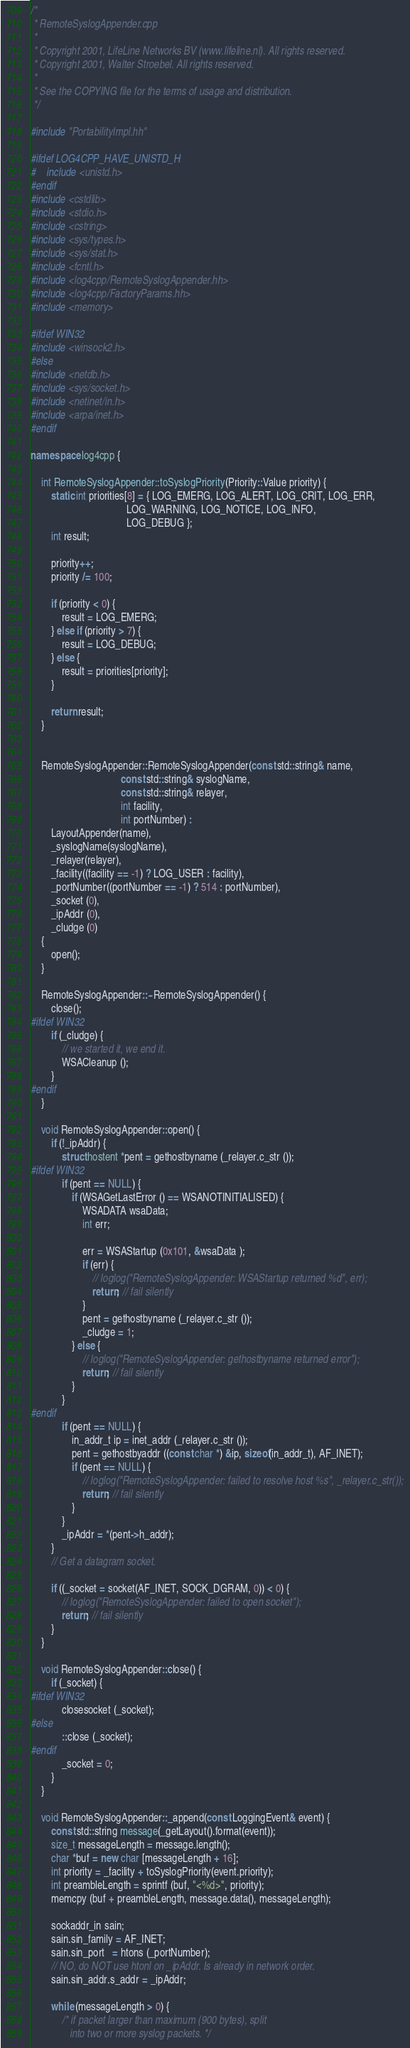<code> <loc_0><loc_0><loc_500><loc_500><_C++_>/*
 * RemoteSyslogAppender.cpp
 *
 * Copyright 2001, LifeLine Networks BV (www.lifeline.nl). All rights reserved.
 * Copyright 2001, Walter Stroebel. All rights reserved.
 *
 * See the COPYING file for the terms of usage and distribution.
 */

#include "PortabilityImpl.hh"

#ifdef LOG4CPP_HAVE_UNISTD_H
#    include <unistd.h>
#endif
#include <cstdlib>
#include <stdio.h>
#include <cstring>
#include <sys/types.h>
#include <sys/stat.h>
#include <fcntl.h>
#include <log4cpp/RemoteSyslogAppender.hh>
#include <log4cpp/FactoryParams.hh>
#include <memory>

#ifdef WIN32
#include <winsock2.h>
#else
#include <netdb.h>
#include <sys/socket.h>
#include <netinet/in.h>
#include <arpa/inet.h>
#endif

namespace log4cpp {

    int RemoteSyslogAppender::toSyslogPriority(Priority::Value priority) {
        static int priorities[8] = { LOG_EMERG, LOG_ALERT, LOG_CRIT, LOG_ERR,
                                     LOG_WARNING, LOG_NOTICE, LOG_INFO, 
                                     LOG_DEBUG };
        int result;

        priority++;
        priority /= 100;

        if (priority < 0) {
            result = LOG_EMERG;
        } else if (priority > 7) {
            result = LOG_DEBUG;
        } else {
            result = priorities[priority];
        }

        return result;
    }
        

    RemoteSyslogAppender::RemoteSyslogAppender(const std::string& name, 
                                   const std::string& syslogName, 
                                   const std::string& relayer,
                                   int facility,
                                   int portNumber) : 
        LayoutAppender(name),
        _syslogName(syslogName),
        _relayer(relayer),
        _facility((facility == -1) ? LOG_USER : facility),
        _portNumber((portNumber == -1) ? 514 : portNumber),
        _socket (0),
        _ipAddr (0),
        _cludge (0)
    {
        open();
    }
    
    RemoteSyslogAppender::~RemoteSyslogAppender() {
        close();
#ifdef WIN32
        if (_cludge) {
            // we started it, we end it.
            WSACleanup ();
        }
#endif
    }

    void RemoteSyslogAppender::open() {
        if (!_ipAddr) {
            struct hostent *pent = gethostbyname (_relayer.c_str ());
#ifdef WIN32
            if (pent == NULL) {
                if (WSAGetLastError () == WSANOTINITIALISED) {
                    WSADATA wsaData;
                    int err;
 
                    err = WSAStartup (0x101, &wsaData );
                    if (err) {
                        // loglog("RemoteSyslogAppender: WSAStartup returned %d", err);
                        return; // fail silently
                    }
                    pent = gethostbyname (_relayer.c_str ());
                    _cludge = 1;
                } else {
                    // loglog("RemoteSyslogAppender: gethostbyname returned error");
                    return; // fail silently
                }
            }
#endif
            if (pent == NULL) {
                in_addr_t ip = inet_addr (_relayer.c_str ());
                pent = gethostbyaddr ((const char *) &ip, sizeof(in_addr_t), AF_INET);
                if (pent == NULL) {
                    // loglog("RemoteSyslogAppender: failed to resolve host %s", _relayer.c_str());
                    return; // fail silently                    
                }
            }
            _ipAddr = *(pent->h_addr);
        }
        // Get a datagram socket.
        
        if ((_socket = socket(AF_INET, SOCK_DGRAM, 0)) < 0) {
            // loglog("RemoteSyslogAppender: failed to open socket");
            return; // fail silently                    
        }
    }

    void RemoteSyslogAppender::close() {
        if (_socket) {
#ifdef WIN32
            closesocket (_socket);
#else
            ::close (_socket);
#endif
            _socket = 0;
        }
    }

    void RemoteSyslogAppender::_append(const LoggingEvent& event) {
        const std::string message(_getLayout().format(event));
        size_t messageLength = message.length();
        char *buf = new char [messageLength + 16];
        int priority = _facility + toSyslogPriority(event.priority);
        int preambleLength = sprintf (buf, "<%d>", priority);
        memcpy (buf + preambleLength, message.data(), messageLength);

        sockaddr_in sain;
        sain.sin_family = AF_INET;
        sain.sin_port   = htons (_portNumber);
        // NO, do NOT use htonl on _ipAddr. Is already in network order.
        sain.sin_addr.s_addr = _ipAddr;

        while (messageLength > 0) {
            /* if packet larger than maximum (900 bytes), split
               into two or more syslog packets. */</code> 